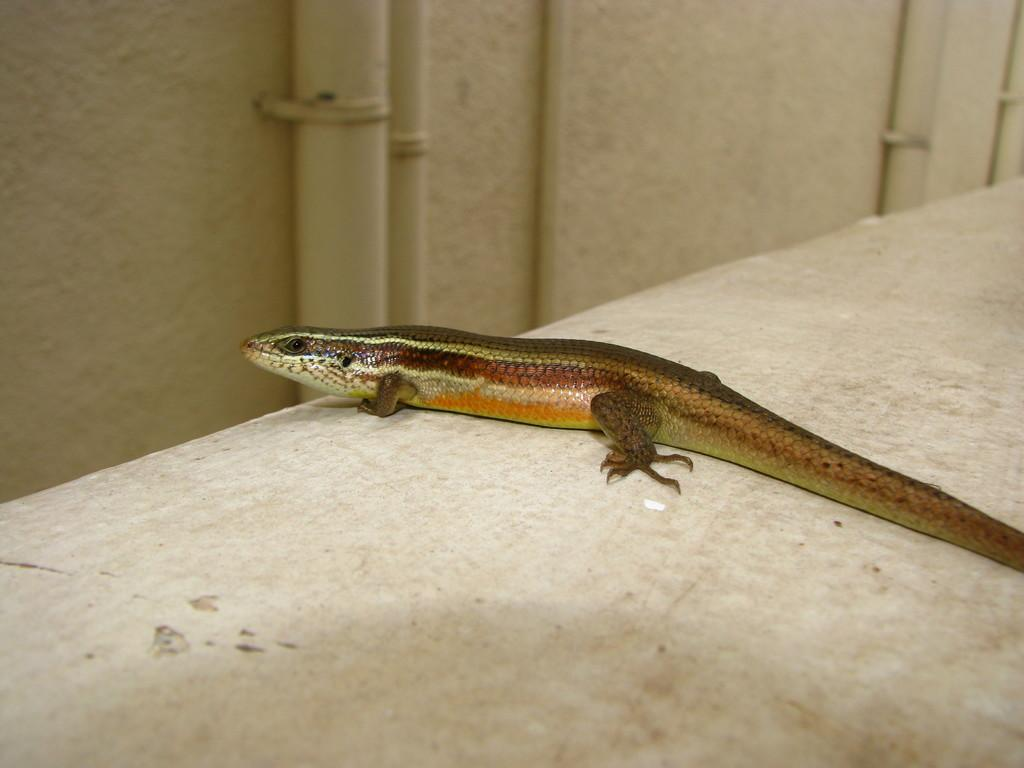What type of animal is in the image? There is a reptile in the image. What is the color of the surface the reptile is on? The reptile is on a white surface. Can you describe any background elements in the image? There is a pipe attached to the wall in the background of the image. What type of seat is the carpenter using in the image? There is no carpenter or seat present in the image; it features a reptile on a white surface with a pipe attached to the wall in the background. 